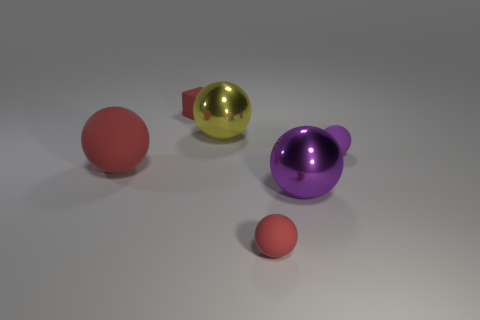Subtract all big metallic balls. How many balls are left? 3 Add 1 tiny brown shiny spheres. How many objects exist? 7 Subtract all purple spheres. How many spheres are left? 3 Subtract 1 cubes. How many cubes are left? 0 Add 4 yellow balls. How many yellow balls are left? 5 Add 3 large yellow objects. How many large yellow objects exist? 4 Subtract 1 red balls. How many objects are left? 5 Subtract all balls. How many objects are left? 1 Subtract all blue spheres. Subtract all purple cylinders. How many spheres are left? 5 Subtract all blue cylinders. How many purple balls are left? 2 